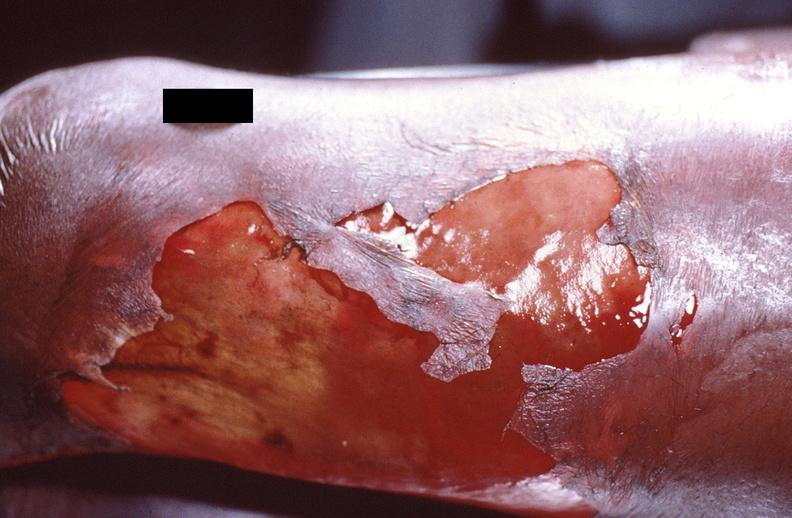does supernumerary digits show panniculitis and fascitis?
Answer the question using a single word or phrase. No 